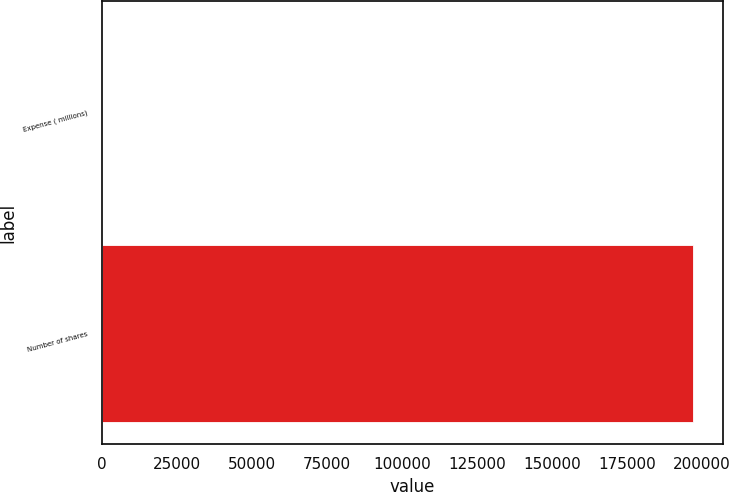<chart> <loc_0><loc_0><loc_500><loc_500><bar_chart><fcel>Expense ( millions)<fcel>Number of shares<nl><fcel>17.1<fcel>197052<nl></chart> 